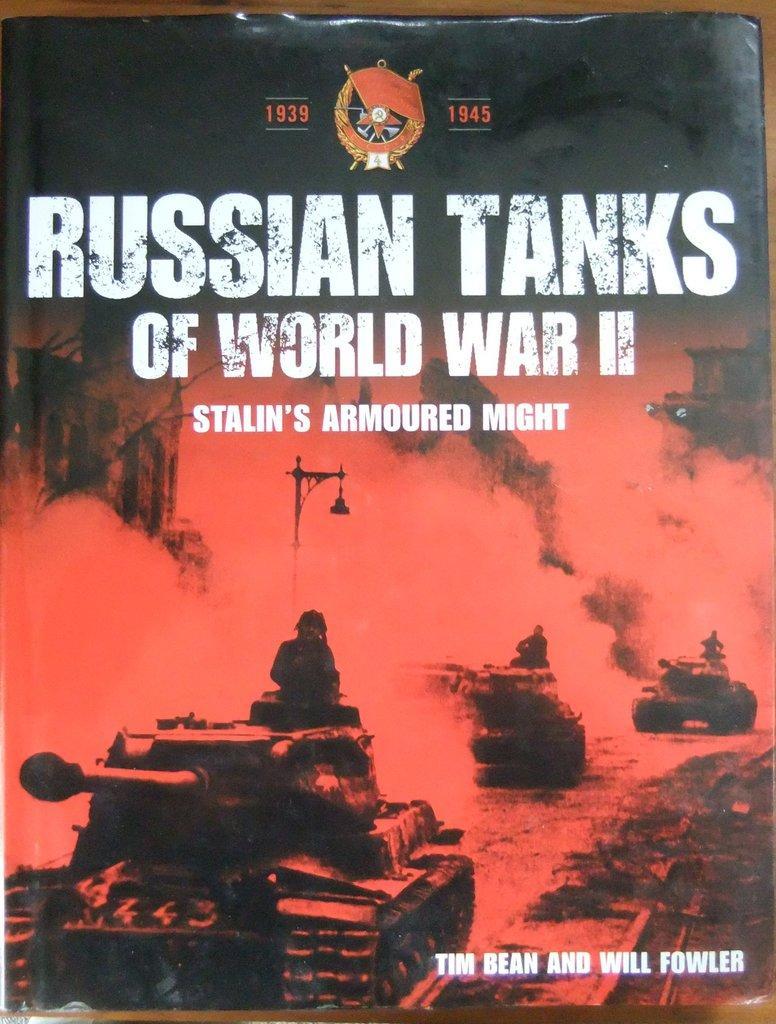Please provide a concise description of this image. In this image I can see the cover page of the book on the brown color surface. On the cover page of the book I can see few people with vehicles, smoke and something is written. 